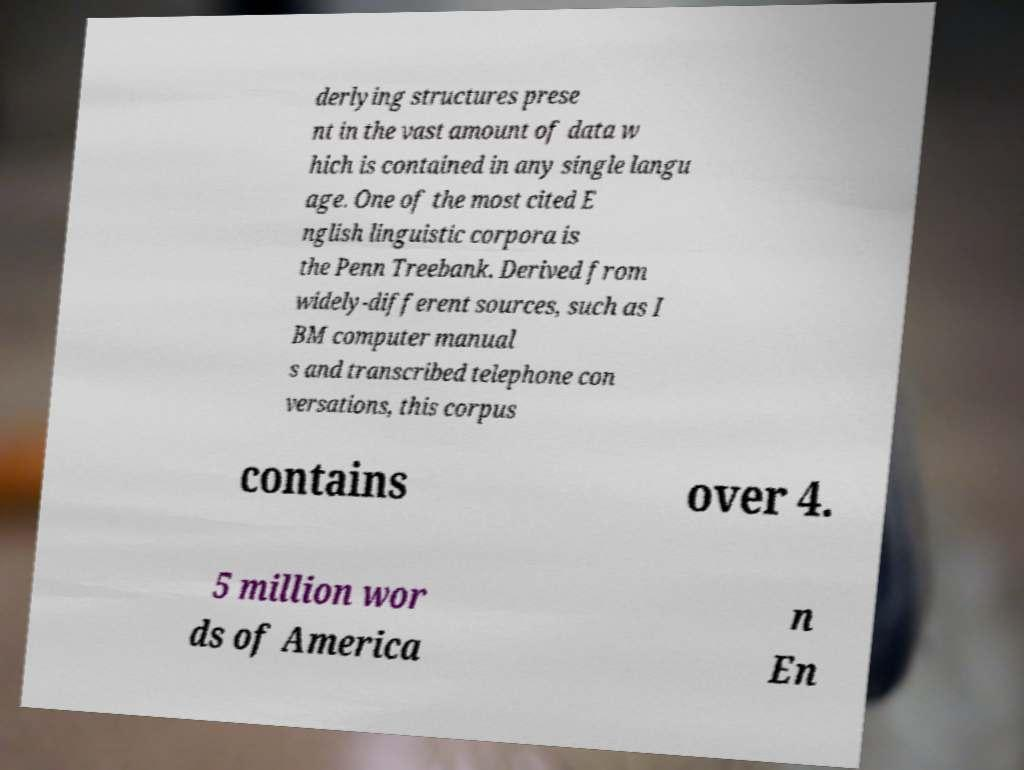Could you assist in decoding the text presented in this image and type it out clearly? derlying structures prese nt in the vast amount of data w hich is contained in any single langu age. One of the most cited E nglish linguistic corpora is the Penn Treebank. Derived from widely-different sources, such as I BM computer manual s and transcribed telephone con versations, this corpus contains over 4. 5 million wor ds of America n En 